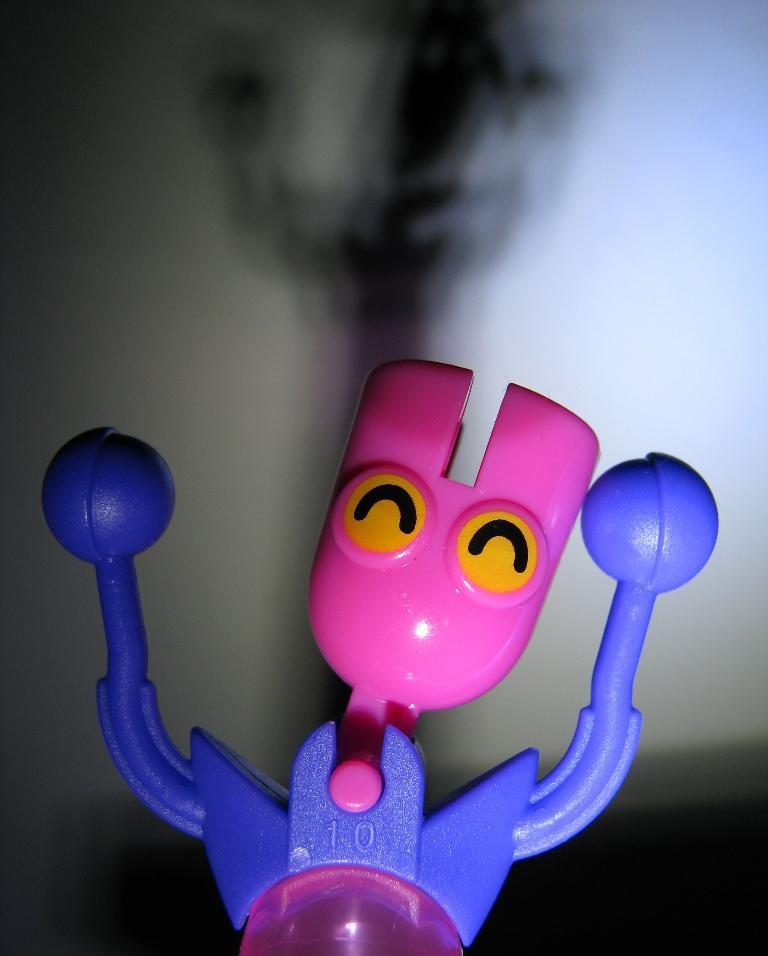What object can be seen in the image that is meant for play or entertainment? There is a toy in the image. What type of background is visible in the image? There is a wall visible in the image. In which direction is the fan blowing in the image? There is no fan present in the image. What is the scale of the toy in the image compared to a real-life object? The scale of the toy cannot be determined from the image alone, as there is no reference object provided. 